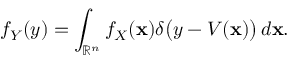Convert formula to latex. <formula><loc_0><loc_0><loc_500><loc_500>f _ { Y } ( y ) = \int _ { { \mathbb { R } } ^ { n } } f _ { X } ( x ) \delta { \left ( } y - V ( x ) { \right ) } \, d x .</formula> 